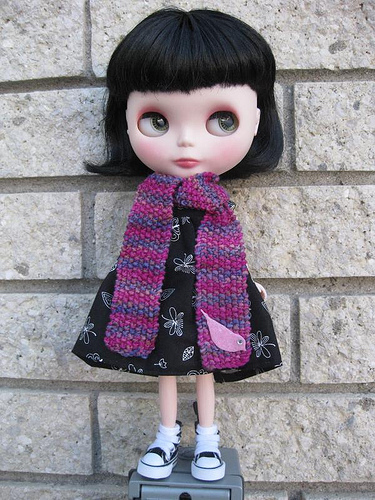<image>
Is there a doll in the house? No. The doll is not contained within the house. These objects have a different spatial relationship. Is the doll in front of the wall? Yes. The doll is positioned in front of the wall, appearing closer to the camera viewpoint. 